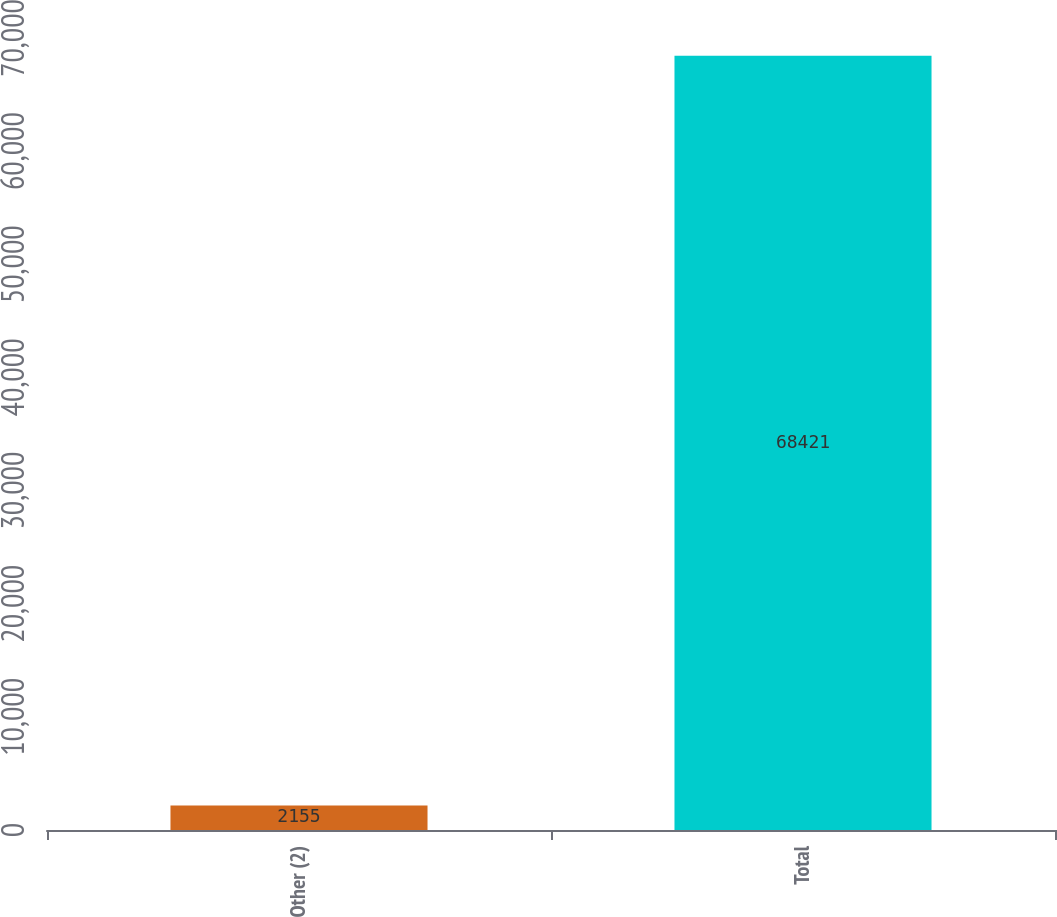Convert chart. <chart><loc_0><loc_0><loc_500><loc_500><bar_chart><fcel>Other (2)<fcel>Total<nl><fcel>2155<fcel>68421<nl></chart> 